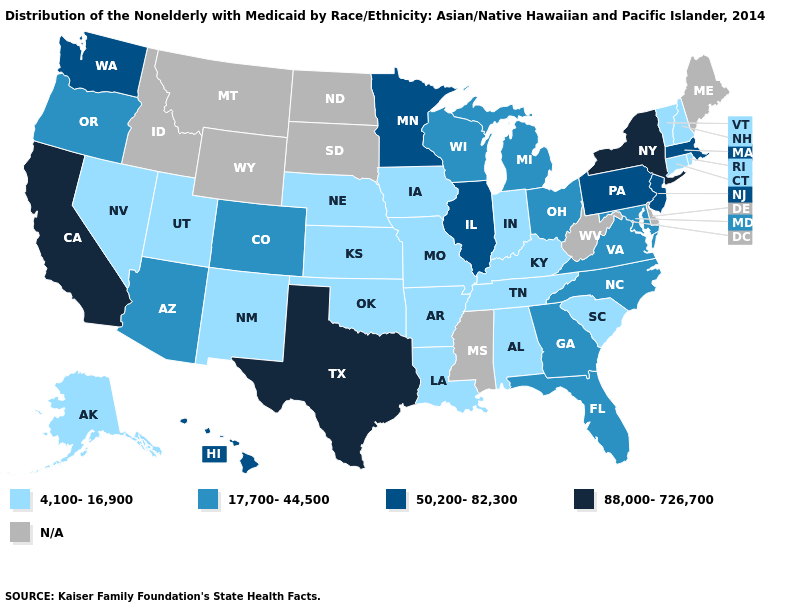Does the first symbol in the legend represent the smallest category?
Give a very brief answer. Yes. Among the states that border Wisconsin , does Minnesota have the highest value?
Keep it brief. Yes. Among the states that border Colorado , does Arizona have the highest value?
Give a very brief answer. Yes. Does Alaska have the lowest value in the USA?
Give a very brief answer. Yes. Which states have the lowest value in the West?
Write a very short answer. Alaska, Nevada, New Mexico, Utah. What is the value of West Virginia?
Keep it brief. N/A. Name the states that have a value in the range 17,700-44,500?
Keep it brief. Arizona, Colorado, Florida, Georgia, Maryland, Michigan, North Carolina, Ohio, Oregon, Virginia, Wisconsin. Name the states that have a value in the range 50,200-82,300?
Answer briefly. Hawaii, Illinois, Massachusetts, Minnesota, New Jersey, Pennsylvania, Washington. Name the states that have a value in the range 17,700-44,500?
Concise answer only. Arizona, Colorado, Florida, Georgia, Maryland, Michigan, North Carolina, Ohio, Oregon, Virginia, Wisconsin. What is the highest value in the USA?
Short answer required. 88,000-726,700. What is the highest value in the USA?
Short answer required. 88,000-726,700. Does Vermont have the lowest value in the Northeast?
Concise answer only. Yes. What is the value of Arkansas?
Quick response, please. 4,100-16,900. Does the map have missing data?
Give a very brief answer. Yes. Name the states that have a value in the range 88,000-726,700?
Be succinct. California, New York, Texas. 